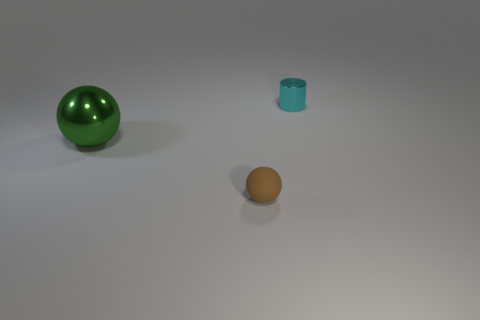Add 1 tiny metal objects. How many objects exist? 4 Subtract 1 cylinders. How many cylinders are left? 0 Subtract all brown spheres. How many spheres are left? 1 Subtract 0 yellow blocks. How many objects are left? 3 Subtract all balls. How many objects are left? 1 Subtract all gray cylinders. Subtract all yellow balls. How many cylinders are left? 1 Subtract all purple blocks. How many red spheres are left? 0 Subtract all small cyan objects. Subtract all tiny brown balls. How many objects are left? 1 Add 2 small brown things. How many small brown things are left? 3 Add 2 large green balls. How many large green balls exist? 3 